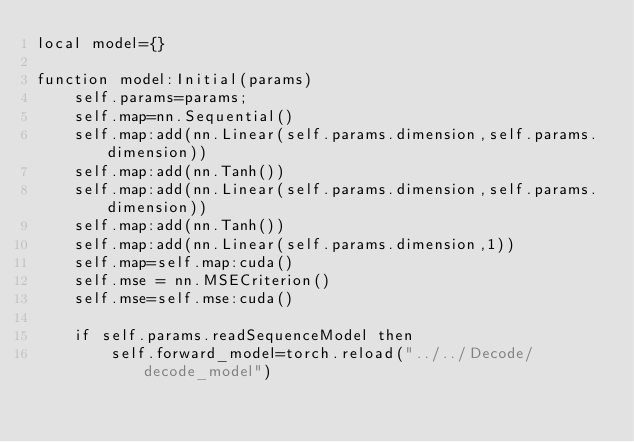Convert code to text. <code><loc_0><loc_0><loc_500><loc_500><_Lua_>local model={}

function model:Initial(params)
    self.params=params;
    self.map=nn.Sequential()
    self.map:add(nn.Linear(self.params.dimension,self.params.dimension))
    self.map:add(nn.Tanh())
    self.map:add(nn.Linear(self.params.dimension,self.params.dimension))
    self.map:add(nn.Tanh())
    self.map:add(nn.Linear(self.params.dimension,1))
    self.map=self.map:cuda()
    self.mse = nn.MSECriterion()
    self.mse=self.mse:cuda()
    
    if self.params.readSequenceModel then
        self.forward_model=torch.reload("../../Decode/decode_model")</code> 